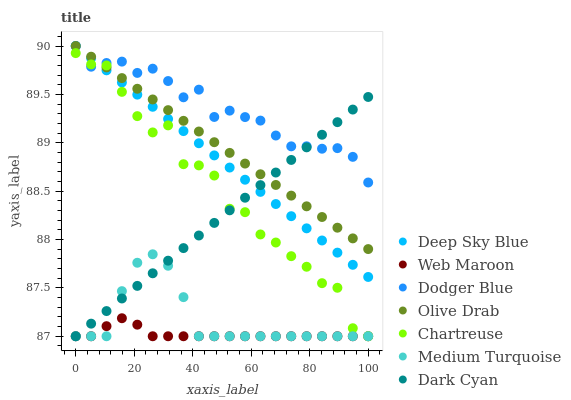Does Web Maroon have the minimum area under the curve?
Answer yes or no. Yes. Does Dodger Blue have the maximum area under the curve?
Answer yes or no. Yes. Does Chartreuse have the minimum area under the curve?
Answer yes or no. No. Does Chartreuse have the maximum area under the curve?
Answer yes or no. No. Is Olive Drab the smoothest?
Answer yes or no. Yes. Is Chartreuse the roughest?
Answer yes or no. Yes. Is Web Maroon the smoothest?
Answer yes or no. No. Is Web Maroon the roughest?
Answer yes or no. No. Does Medium Turquoise have the lowest value?
Answer yes or no. Yes. Does Dodger Blue have the lowest value?
Answer yes or no. No. Does Olive Drab have the highest value?
Answer yes or no. Yes. Does Chartreuse have the highest value?
Answer yes or no. No. Is Web Maroon less than Dodger Blue?
Answer yes or no. Yes. Is Dodger Blue greater than Web Maroon?
Answer yes or no. Yes. Does Olive Drab intersect Dark Cyan?
Answer yes or no. Yes. Is Olive Drab less than Dark Cyan?
Answer yes or no. No. Is Olive Drab greater than Dark Cyan?
Answer yes or no. No. Does Web Maroon intersect Dodger Blue?
Answer yes or no. No. 